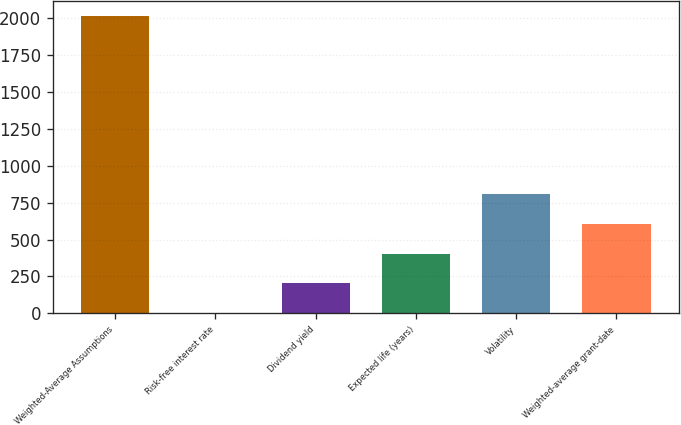Convert chart. <chart><loc_0><loc_0><loc_500><loc_500><bar_chart><fcel>Weighted-Average Assumptions<fcel>Risk-free interest rate<fcel>Dividend yield<fcel>Expected life (years)<fcel>Volatility<fcel>Weighted-average grant-date<nl><fcel>2015<fcel>1.3<fcel>202.67<fcel>404.04<fcel>806.78<fcel>605.41<nl></chart> 